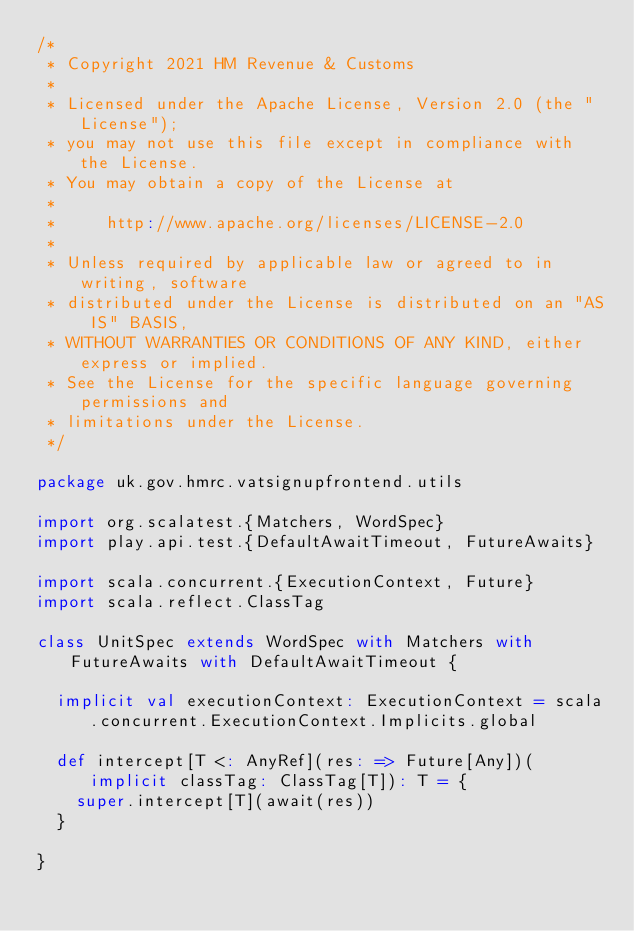<code> <loc_0><loc_0><loc_500><loc_500><_Scala_>/*
 * Copyright 2021 HM Revenue & Customs
 *
 * Licensed under the Apache License, Version 2.0 (the "License");
 * you may not use this file except in compliance with the License.
 * You may obtain a copy of the License at
 *
 *     http://www.apache.org/licenses/LICENSE-2.0
 *
 * Unless required by applicable law or agreed to in writing, software
 * distributed under the License is distributed on an "AS IS" BASIS,
 * WITHOUT WARRANTIES OR CONDITIONS OF ANY KIND, either express or implied.
 * See the License for the specific language governing permissions and
 * limitations under the License.
 */

package uk.gov.hmrc.vatsignupfrontend.utils

import org.scalatest.{Matchers, WordSpec}
import play.api.test.{DefaultAwaitTimeout, FutureAwaits}

import scala.concurrent.{ExecutionContext, Future}
import scala.reflect.ClassTag

class UnitSpec extends WordSpec with Matchers with FutureAwaits with DefaultAwaitTimeout {

  implicit val executionContext: ExecutionContext = scala.concurrent.ExecutionContext.Implicits.global

  def intercept[T <: AnyRef](res: => Future[Any])(implicit classTag: ClassTag[T]): T = {
    super.intercept[T](await(res))
  }

}
</code> 